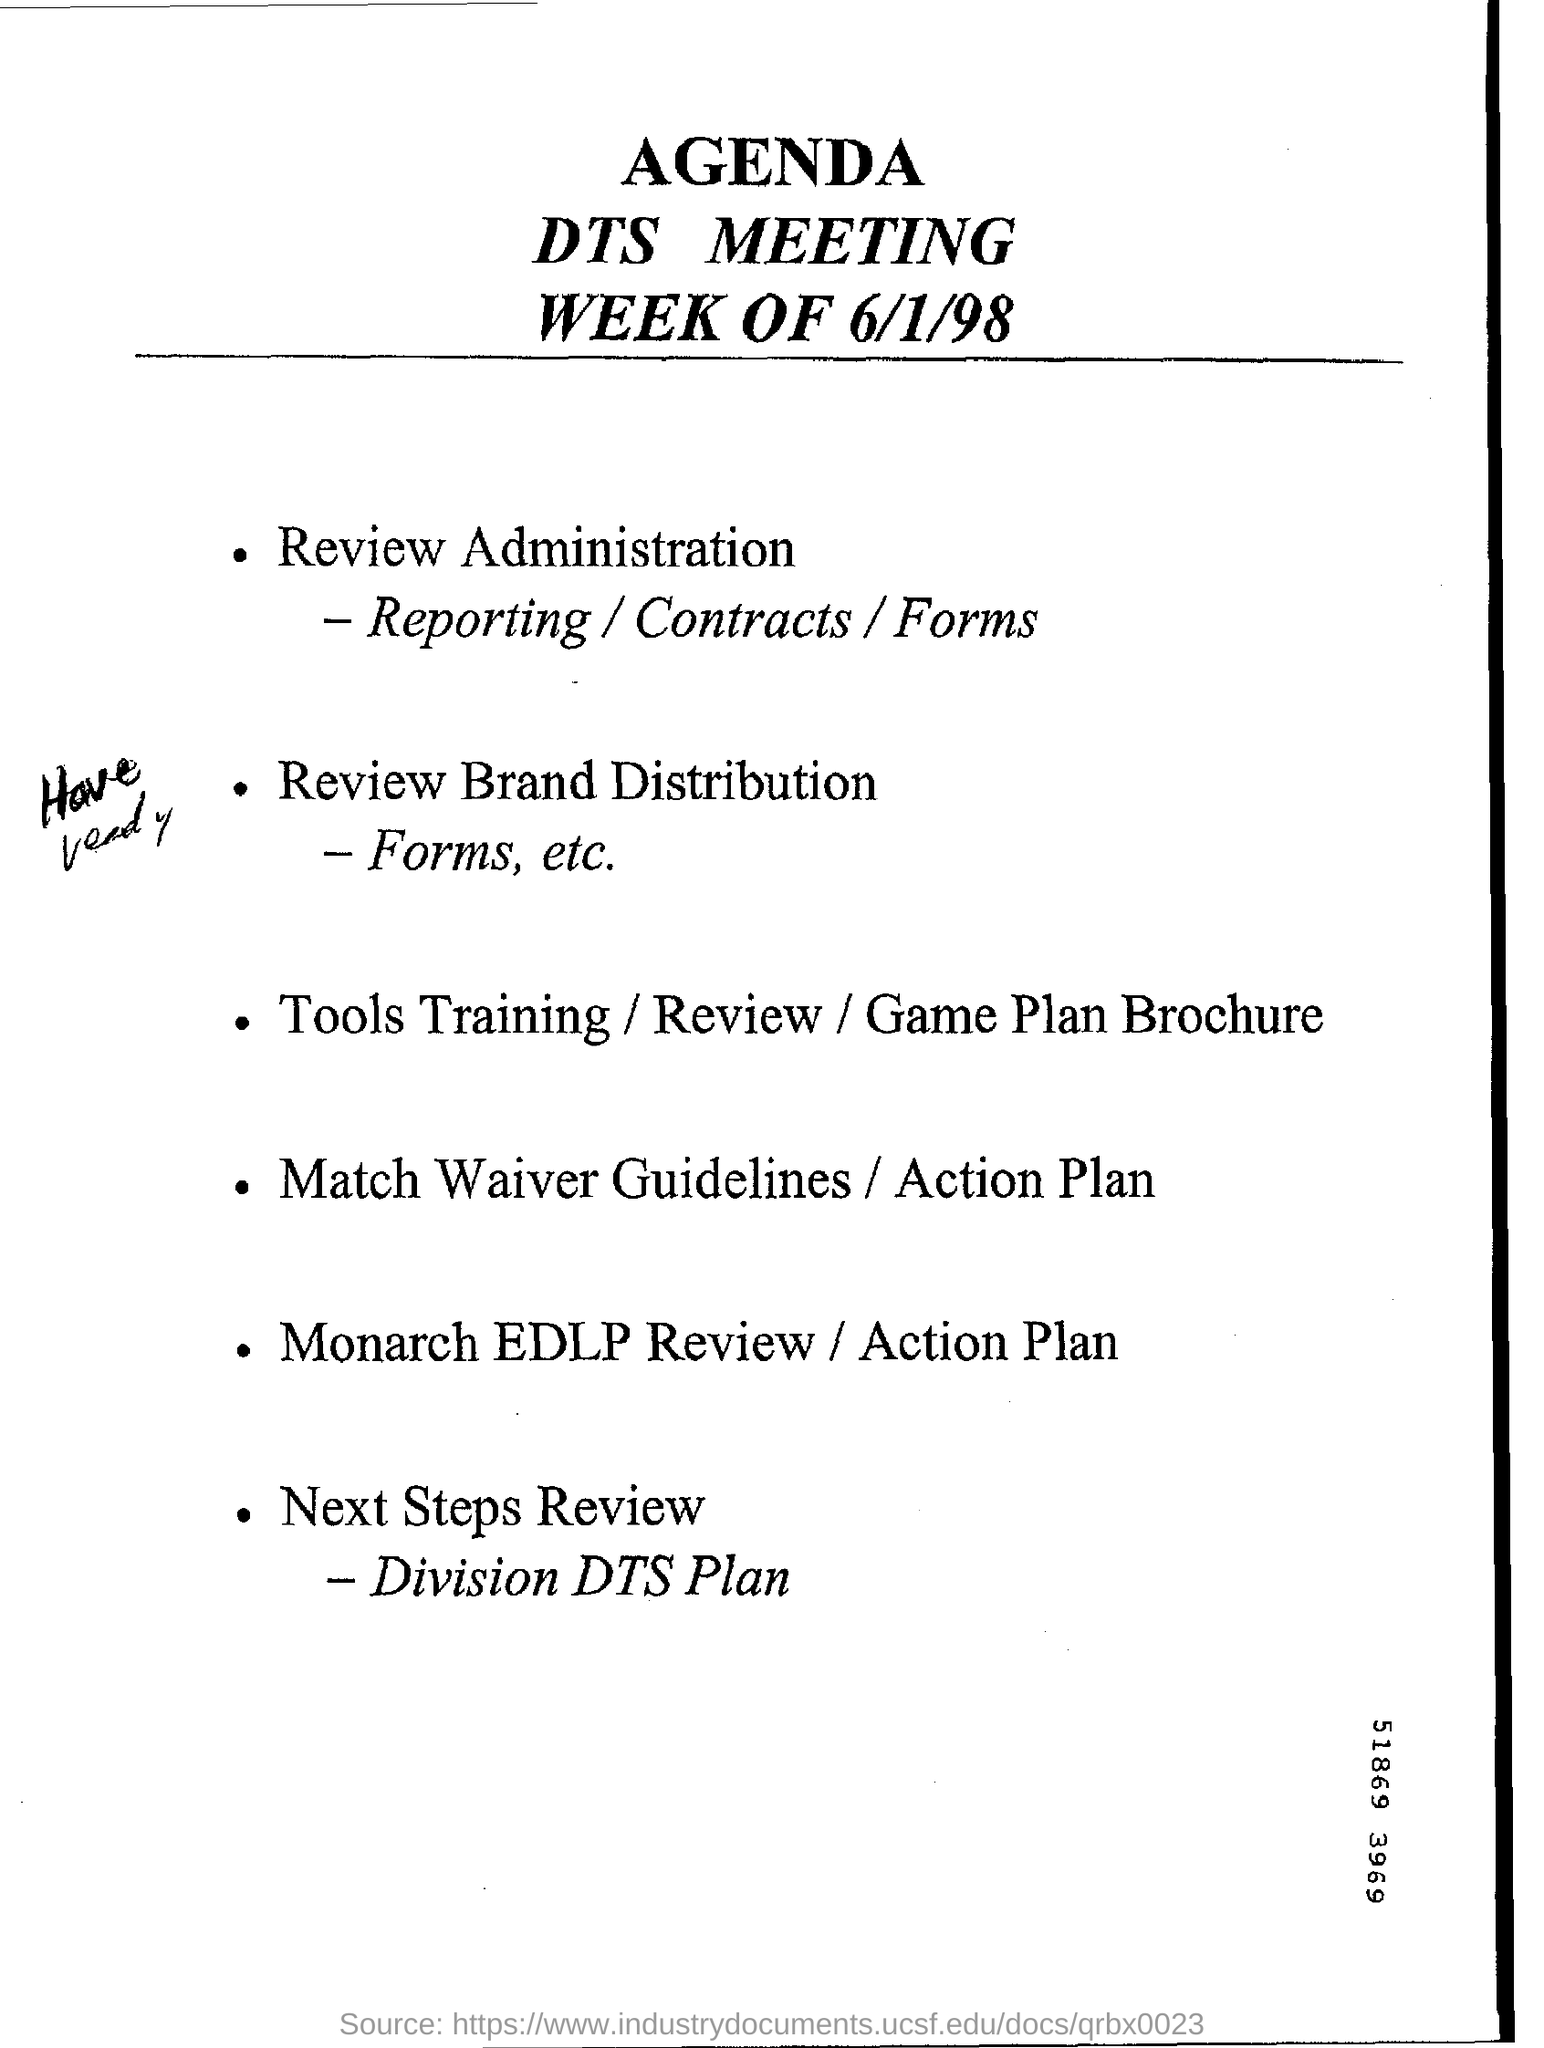Which meeting agenda is given here?
Your response must be concise. AGENDA DTS MEETING. What is the date mentioned in this document?
Keep it short and to the point. 6/1/98. 